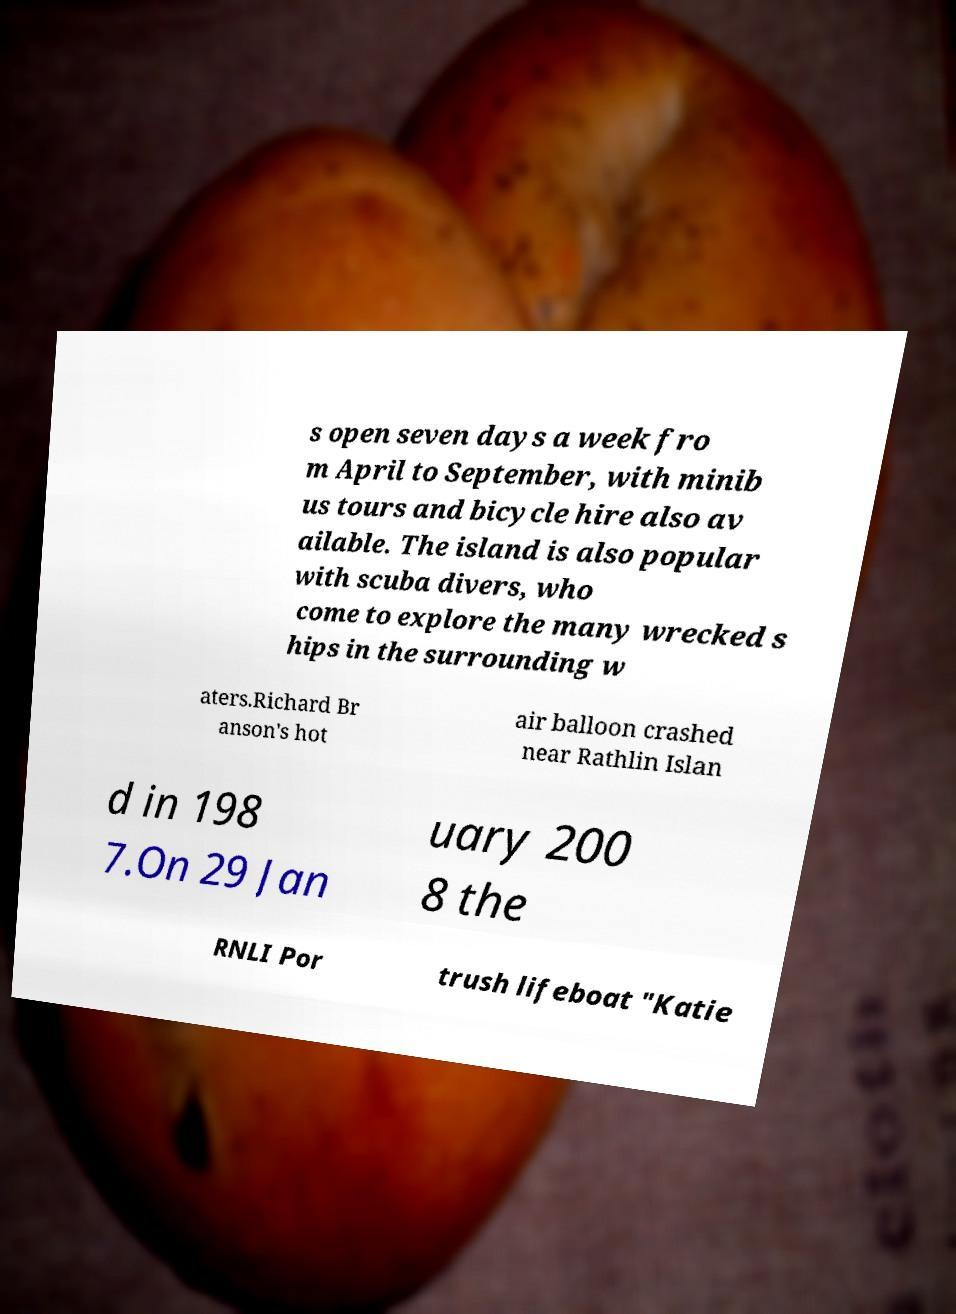Please read and relay the text visible in this image. What does it say? s open seven days a week fro m April to September, with minib us tours and bicycle hire also av ailable. The island is also popular with scuba divers, who come to explore the many wrecked s hips in the surrounding w aters.Richard Br anson's hot air balloon crashed near Rathlin Islan d in 198 7.On 29 Jan uary 200 8 the RNLI Por trush lifeboat "Katie 